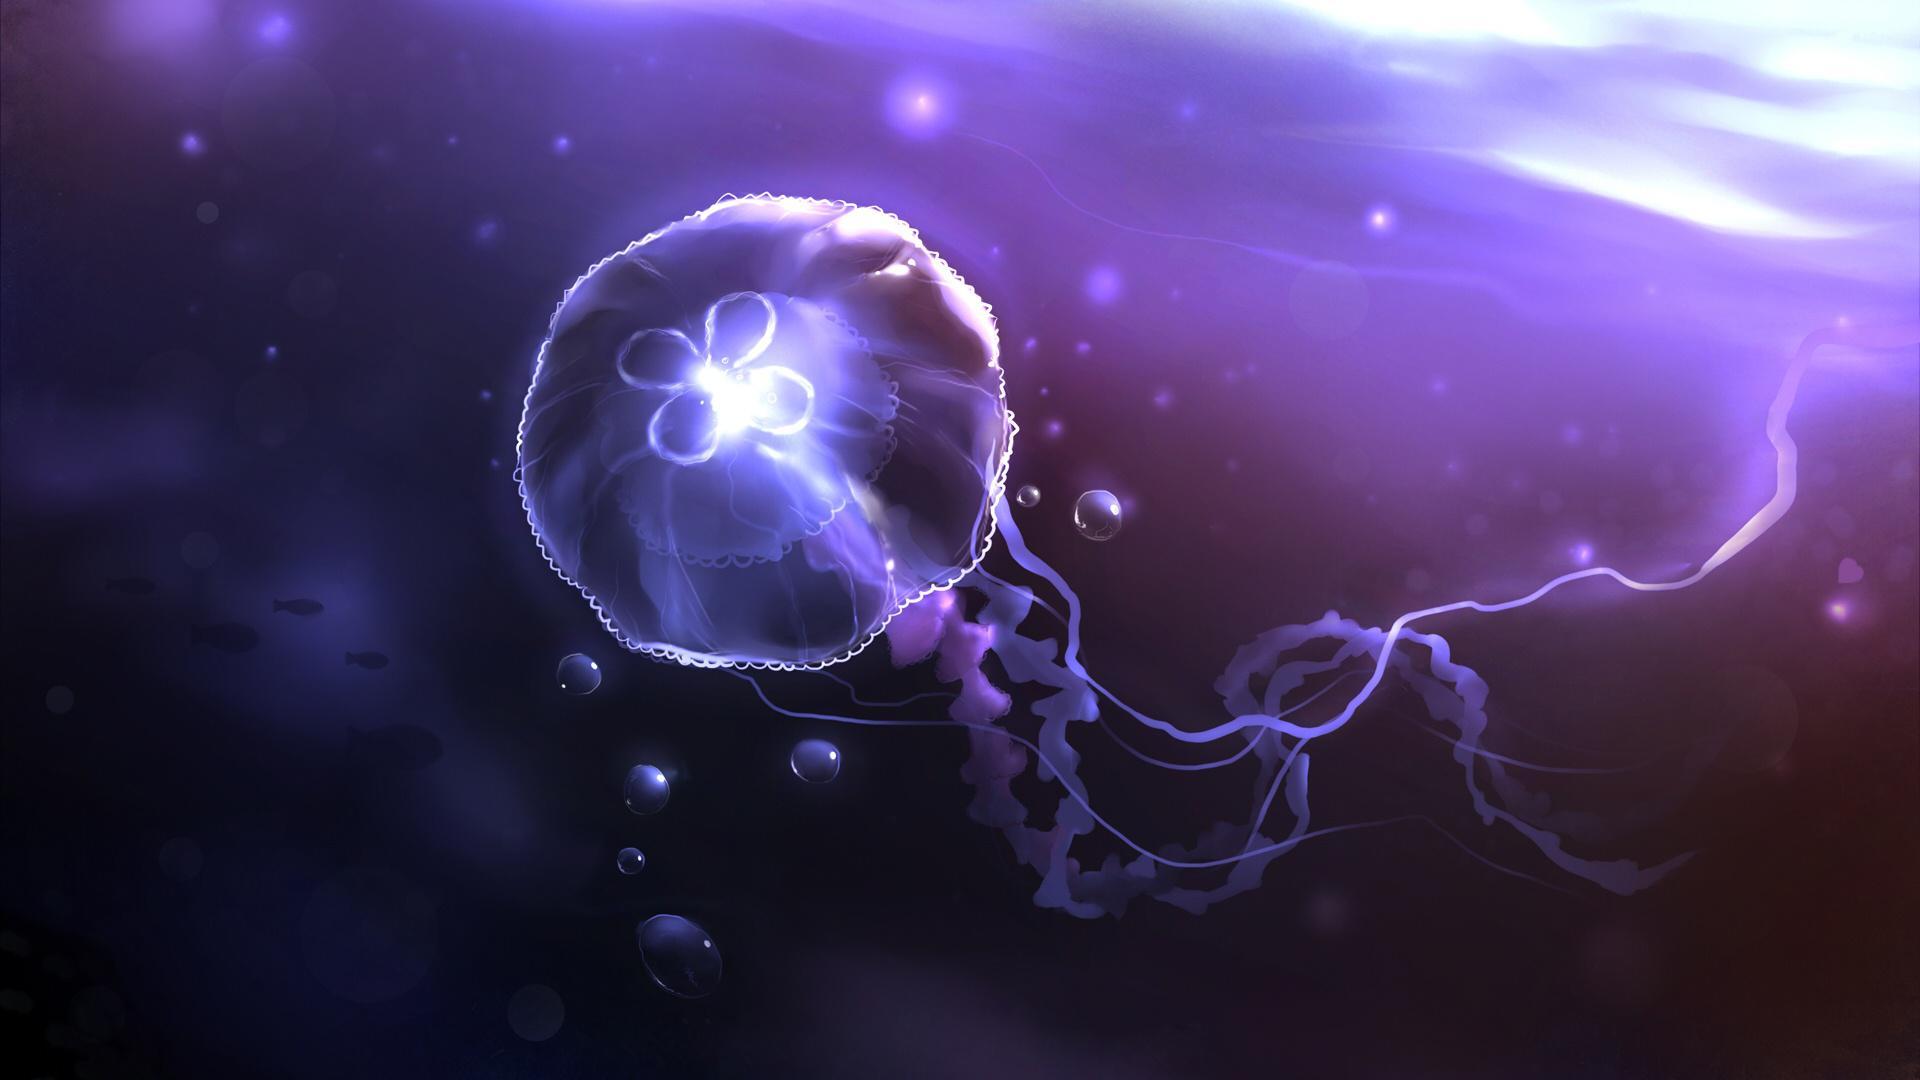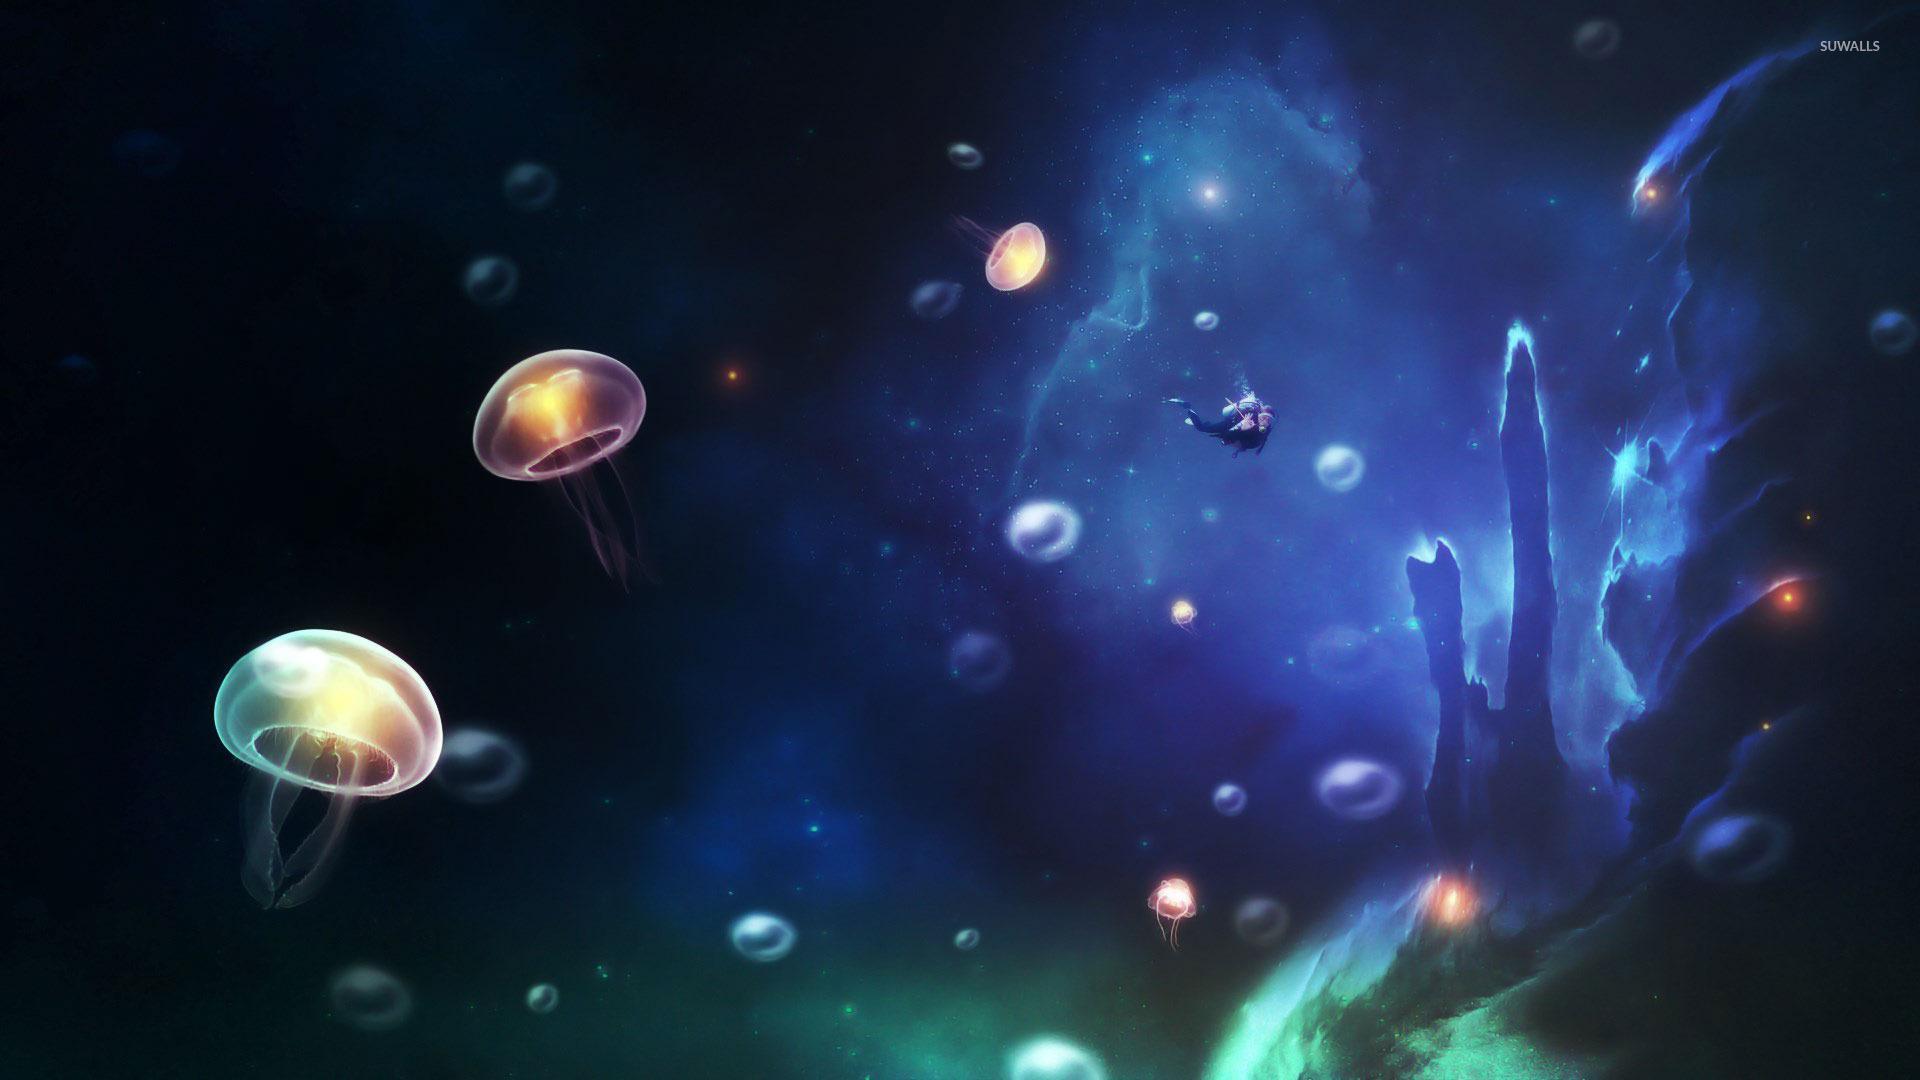The first image is the image on the left, the second image is the image on the right. Analyze the images presented: Is the assertion "There are no more than 5 jellyfish in the image on the right." valid? Answer yes or no. No. 